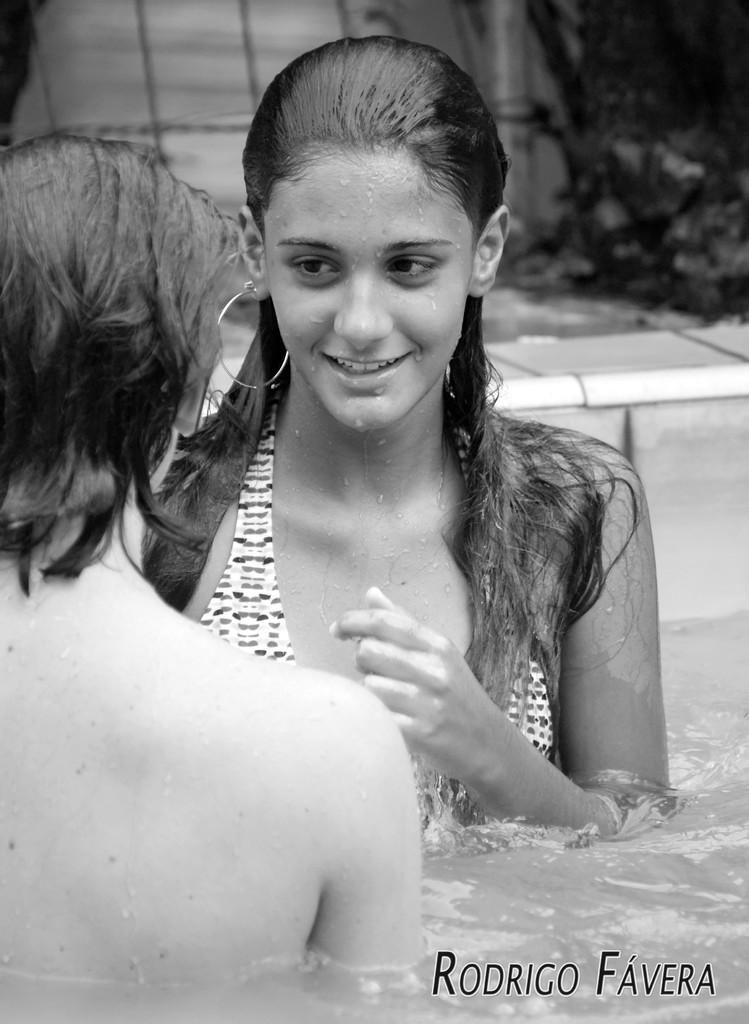What is the color scheme of the image? The image is black and white. How many people are in the water in the image? There are two persons in the water. What can be seen in the image besides the people in the water? There is a path visible in the image, as well as plants in the background. What is present at the bottom of the image? There is text at the bottom of the image. What color are the eyes of the person in the water? There is no information about the color of the person's eyes in the image, as it is black and white. How much dirt is visible in the image? There is no dirt visible in the image; it features a black and white scene with two people in the water, a path, plants, and text. 